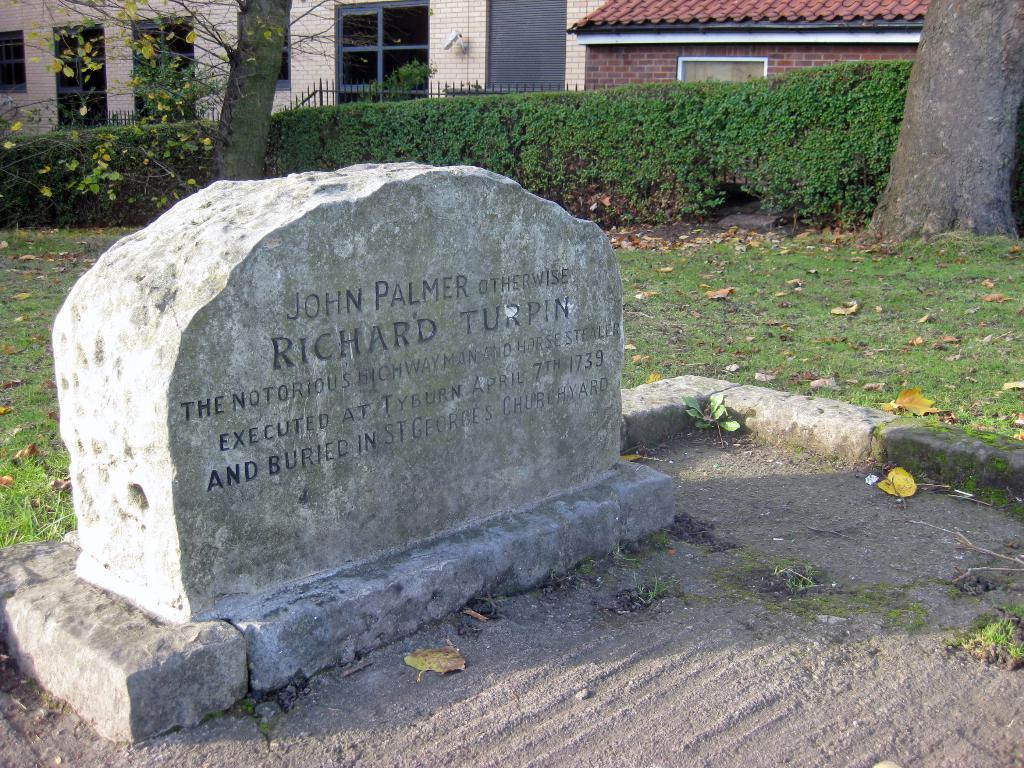What is located on the path in the image? There is a grave on a path in the image. What can be seen in the distance behind the grave? There are houses, trees, and plants in the background of the image. What type of mask is the kitten wearing in the image? There is no kitten or mask present in the image. What does the caption say about the grave in the image? There is no caption present in the image. 